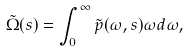<formula> <loc_0><loc_0><loc_500><loc_500>\tilde { \Omega } ( s ) = \int _ { 0 } ^ { \infty } \tilde { p } ( \omega , s ) \omega d \omega ,</formula> 